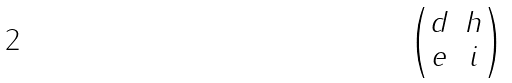Convert formula to latex. <formula><loc_0><loc_0><loc_500><loc_500>\begin{pmatrix} d & h \\ e & i \end{pmatrix}</formula> 